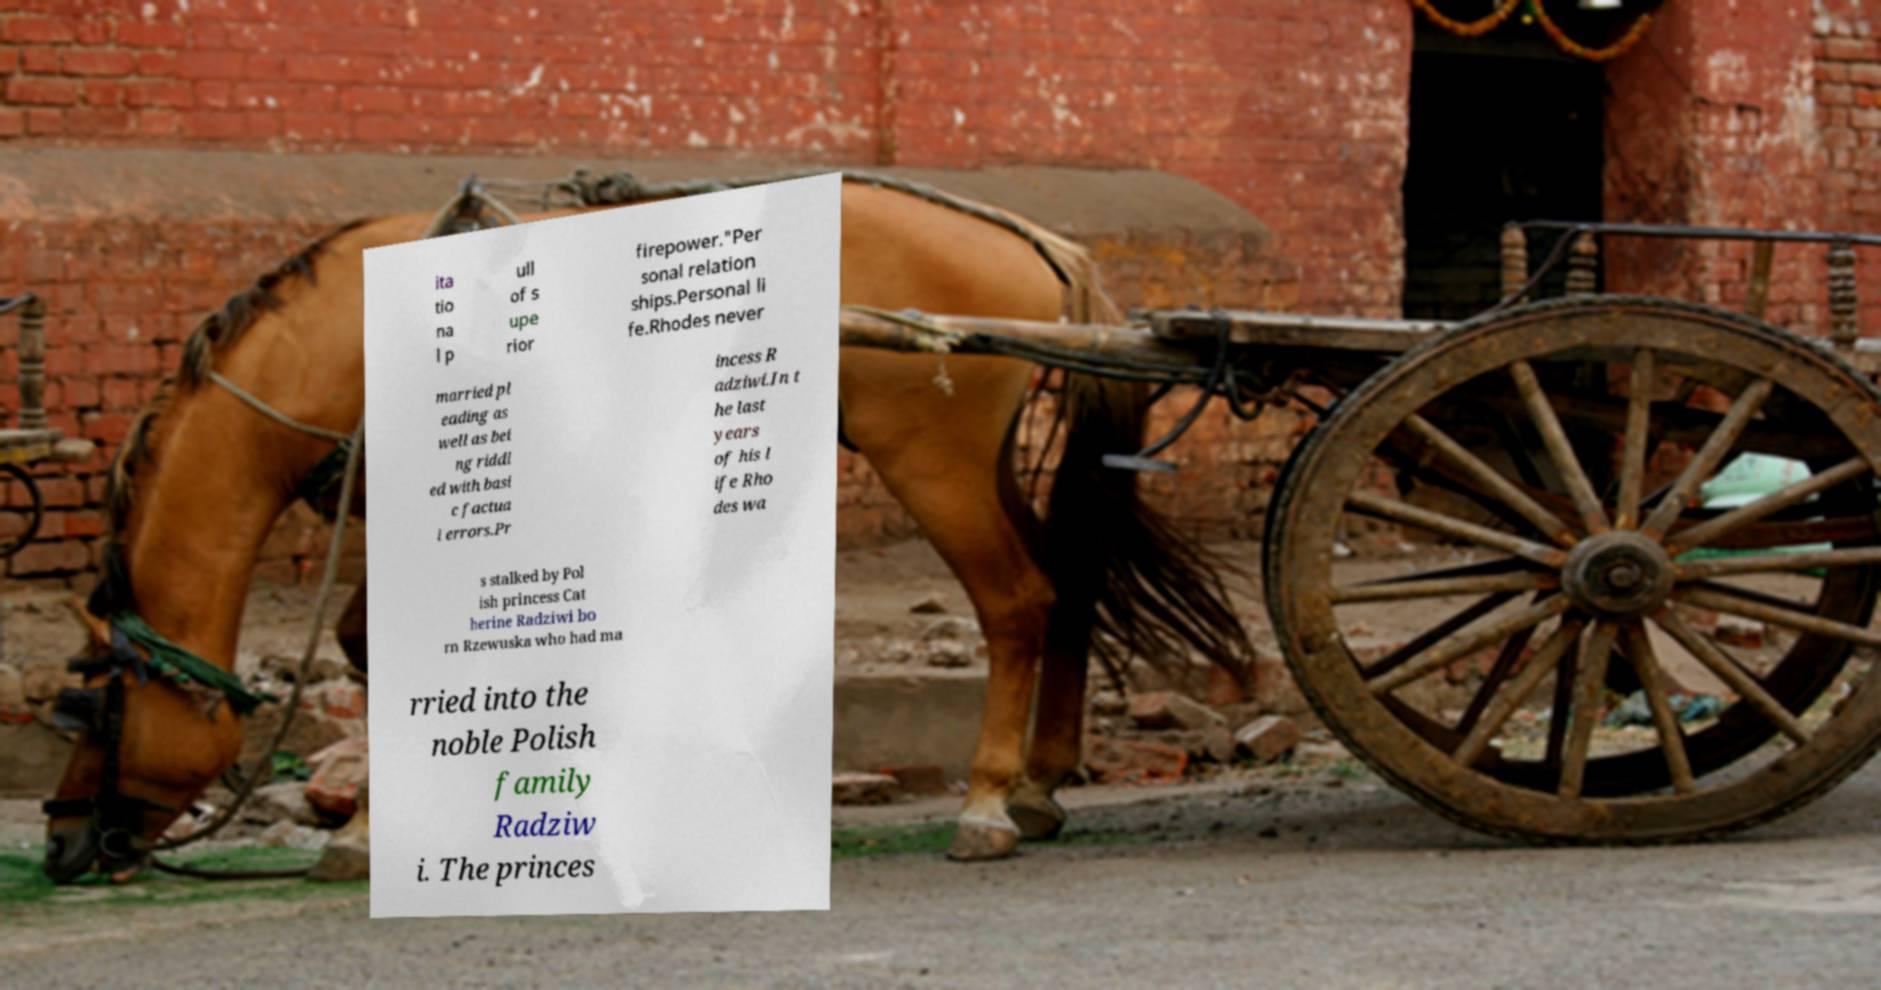I need the written content from this picture converted into text. Can you do that? ita tio na l p ull of s upe rior firepower."Per sonal relation ships.Personal li fe.Rhodes never married pl eading as well as bei ng riddl ed with basi c factua l errors.Pr incess R adziwi.In t he last years of his l ife Rho des wa s stalked by Pol ish princess Cat herine Radziwi bo rn Rzewuska who had ma rried into the noble Polish family Radziw i. The princes 